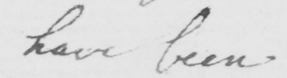What does this handwritten line say? have been 